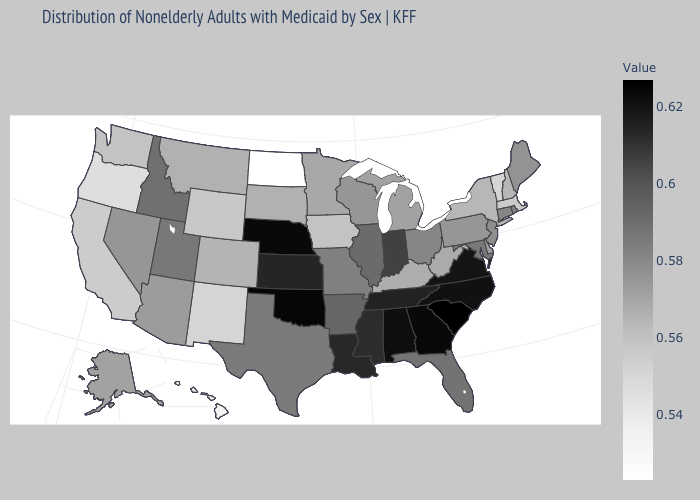Among the states that border New Hampshire , does Massachusetts have the lowest value?
Quick response, please. No. 